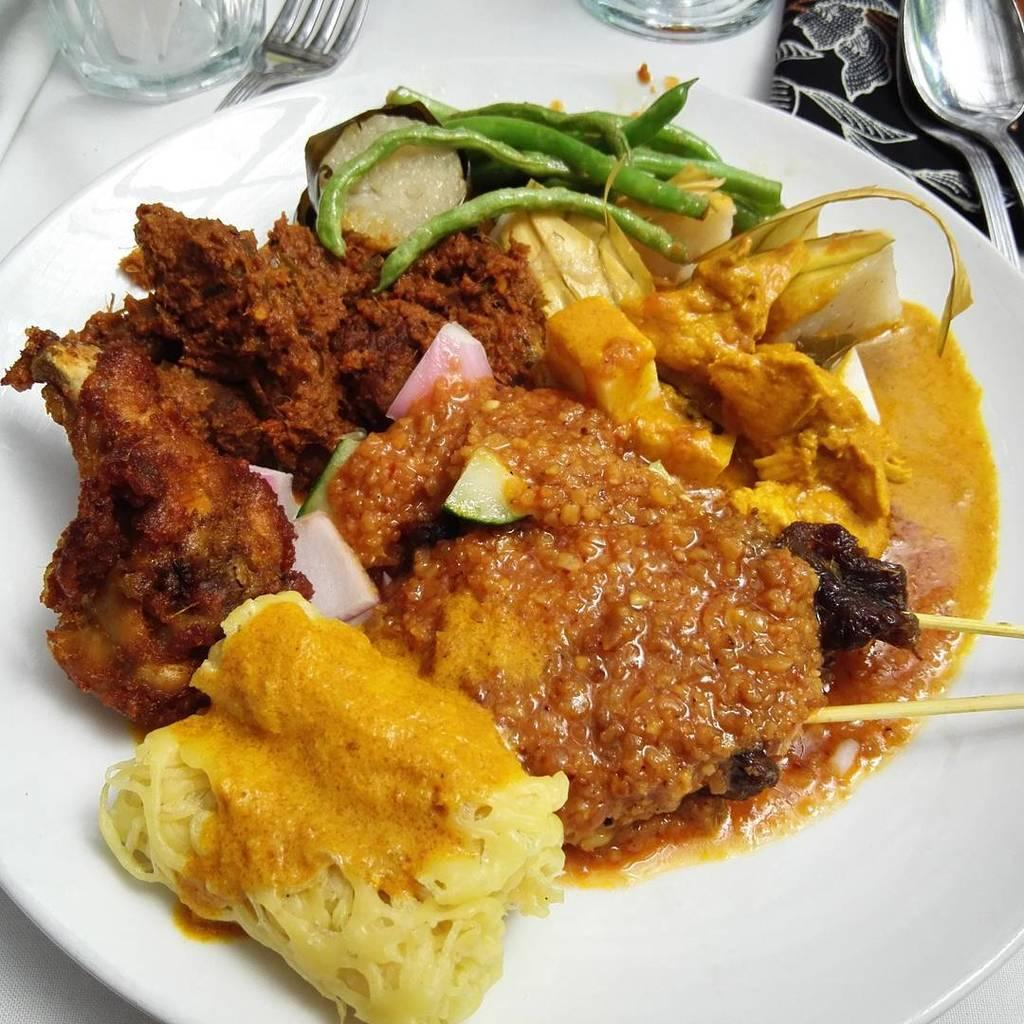What is present on the plate in the image? There are food items on the plate in the image. What other items can be seen in the image besides the plate? There are glasses, a fork, and spoons on an object in the image. What type of yoke is used to hold the glasses in the image? There is no yoke present in the image; the glasses are resting on an object, likely a table or countertop. 